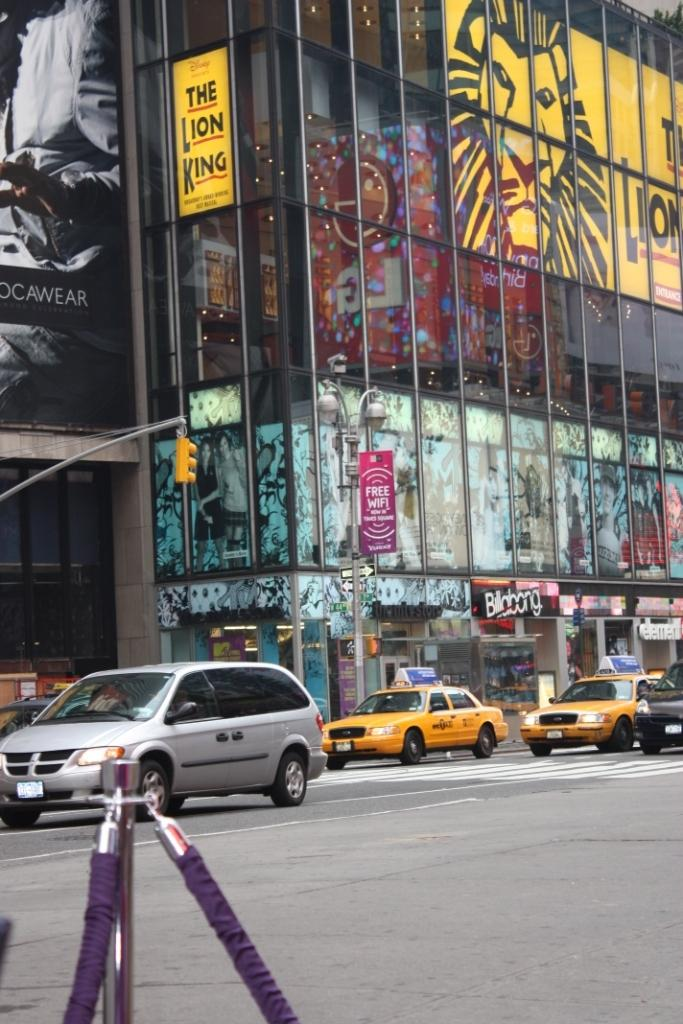<image>
Relay a brief, clear account of the picture shown. Billabong, and the Lion King building that is offering free wifi. 